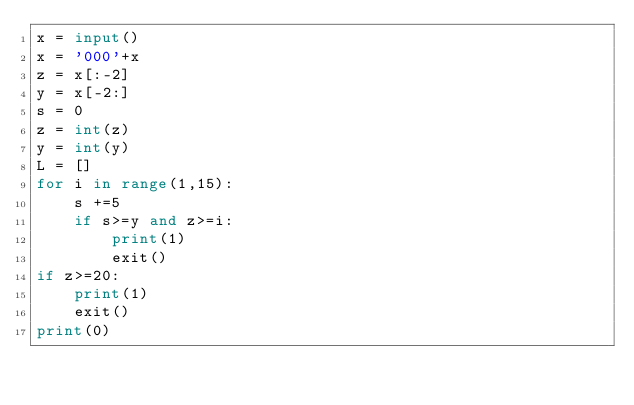Convert code to text. <code><loc_0><loc_0><loc_500><loc_500><_Python_>x = input()
x = '000'+x
z = x[:-2]
y = x[-2:]
s = 0
z = int(z)
y = int(y)
L = []
for i in range(1,15):
    s +=5
    if s>=y and z>=i:
        print(1)
        exit()
if z>=20:
    print(1)
    exit()
print(0)</code> 